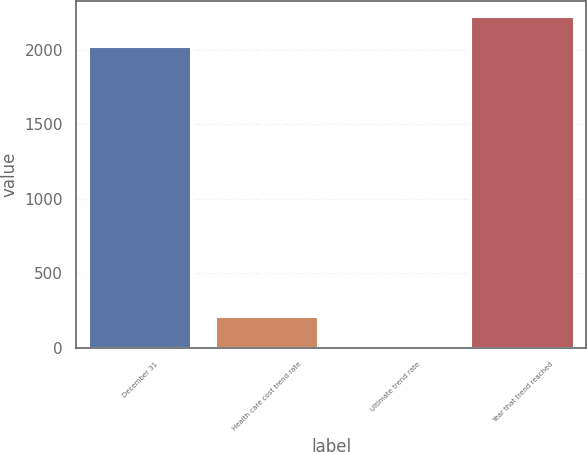Convert chart to OTSL. <chart><loc_0><loc_0><loc_500><loc_500><bar_chart><fcel>December 31<fcel>Health care cost trend rate<fcel>Ultimate trend rate<fcel>Year that trend reached<nl><fcel>2016<fcel>206.6<fcel>5<fcel>2217.6<nl></chart> 